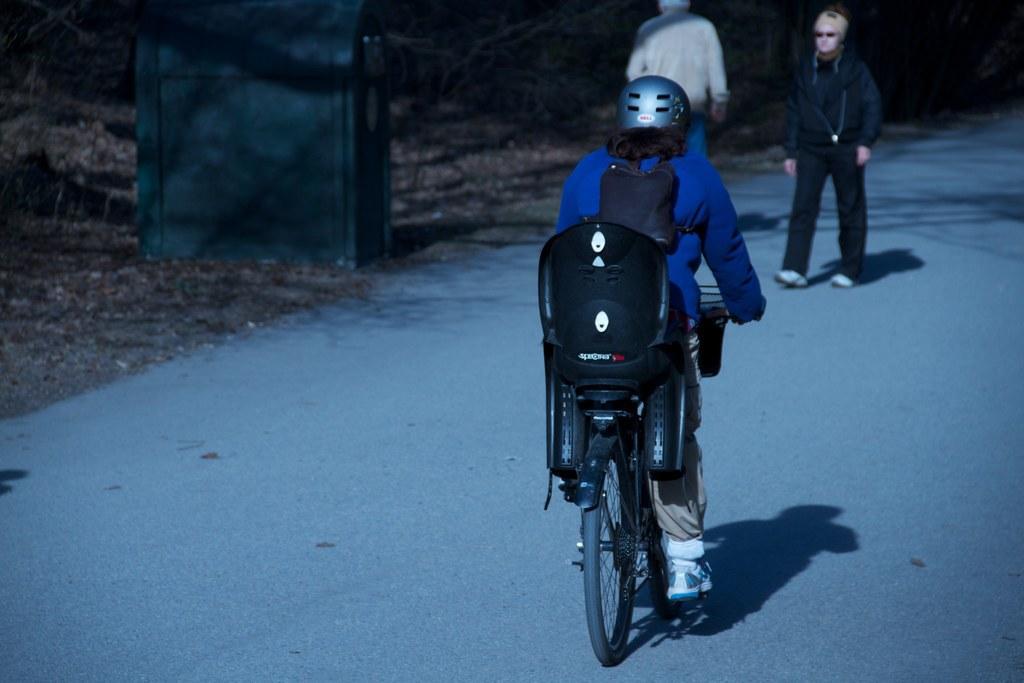In one or two sentences, can you explain what this image depicts? As we can see in the image, there are three persons. The person in the front is riding bicycle and wearing shoes. 